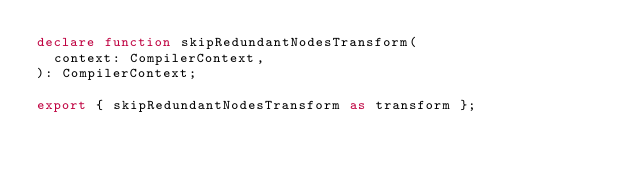Convert code to text. <code><loc_0><loc_0><loc_500><loc_500><_TypeScript_>declare function skipRedundantNodesTransform(
  context: CompilerContext,
): CompilerContext;

export { skipRedundantNodesTransform as transform };
</code> 